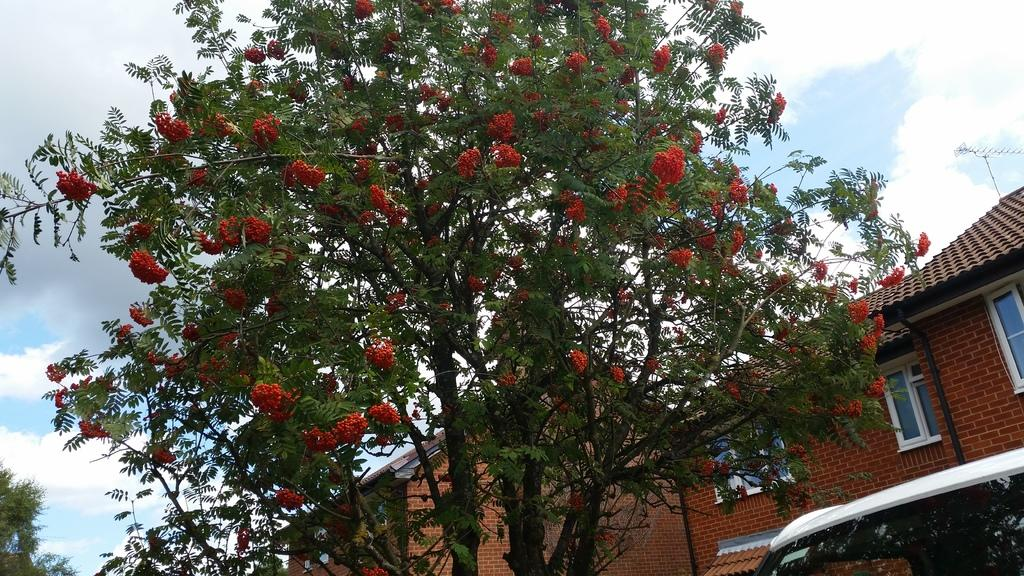What type of plants can be seen in the image? There are flowers and trees in the image. What type of structures are present in the image? There are buildings in the image. What type of transportation is visible in the image? There is a vehicle in the image. What type of communication device is present in the image? There is an antenna in the image. How many sons can be seen in the image? There are no sons present in the image. 